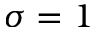Convert formula to latex. <formula><loc_0><loc_0><loc_500><loc_500>\sigma = 1</formula> 